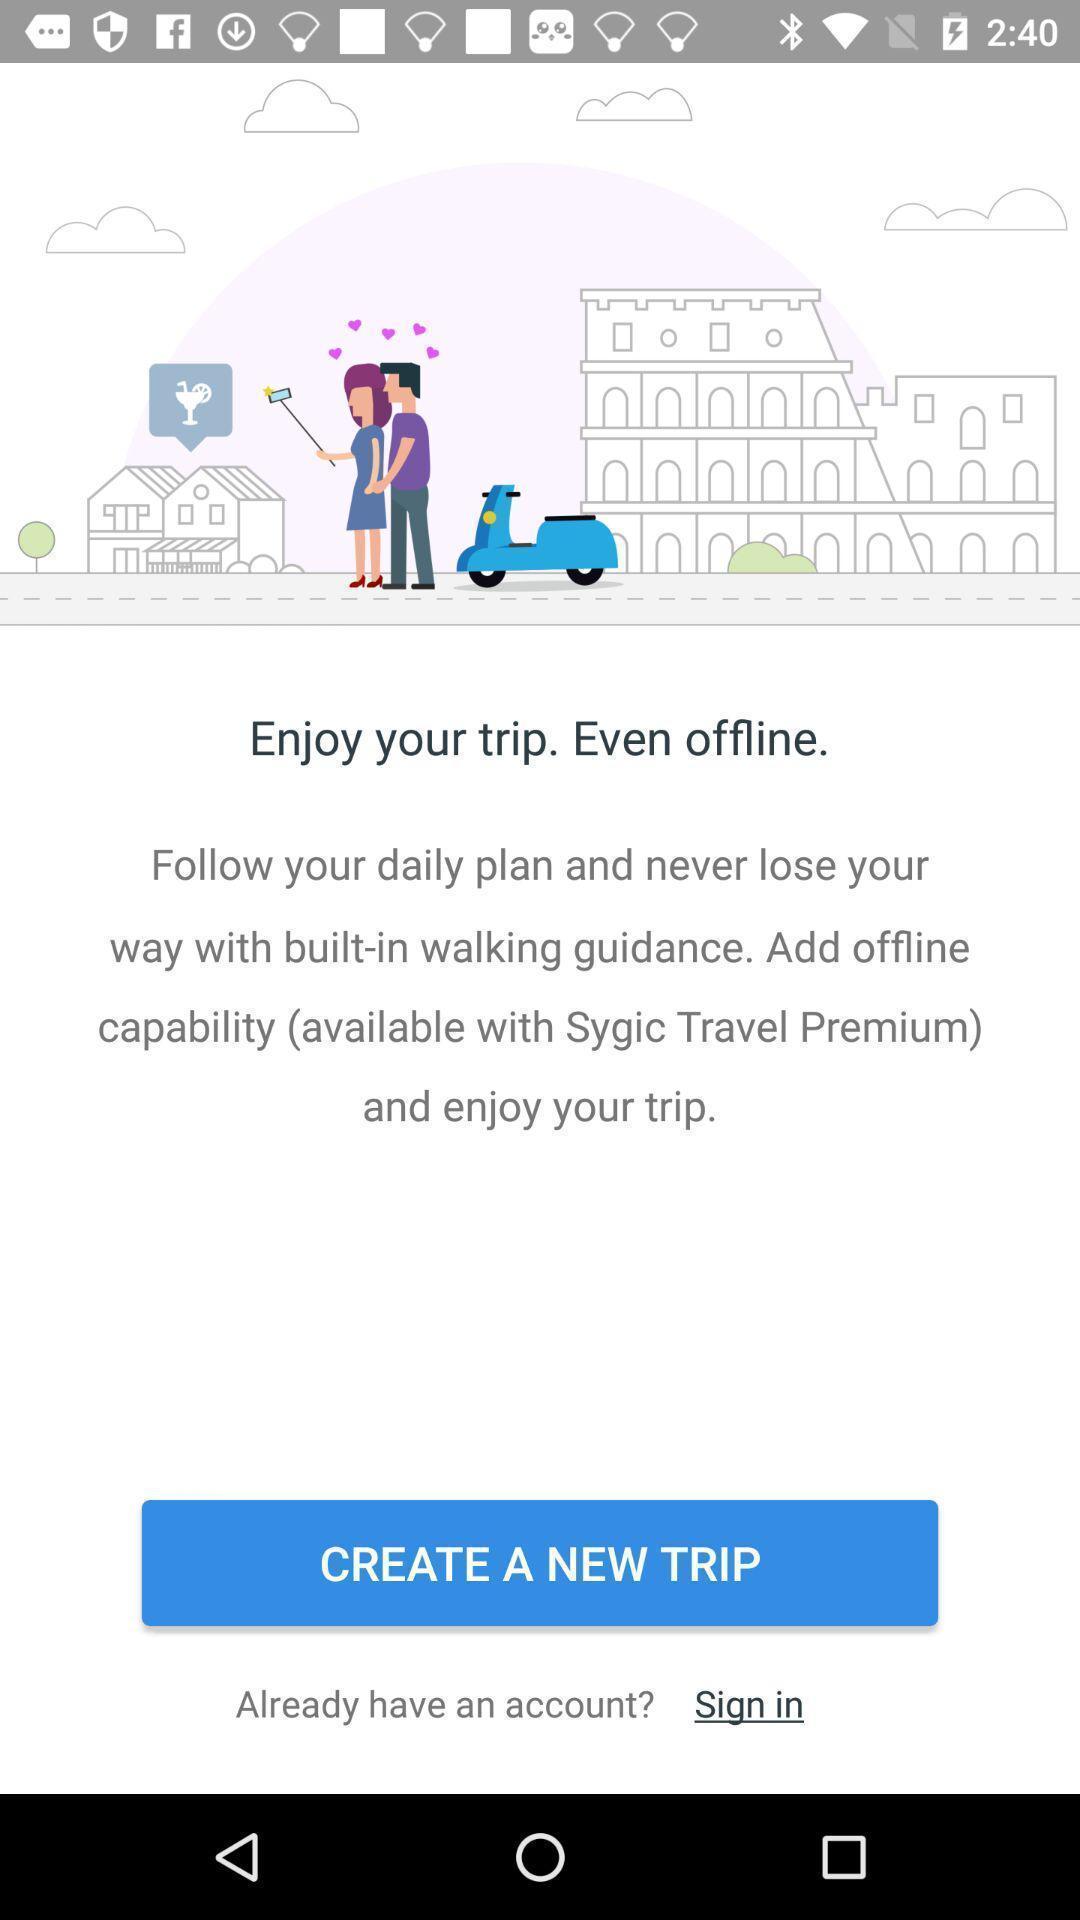What can you discern from this picture? Sign in page. 